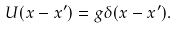Convert formula to latex. <formula><loc_0><loc_0><loc_500><loc_500>U ( { x } - { x } ^ { \prime } ) = g \delta ( { x } - { x } ^ { \prime } ) .</formula> 